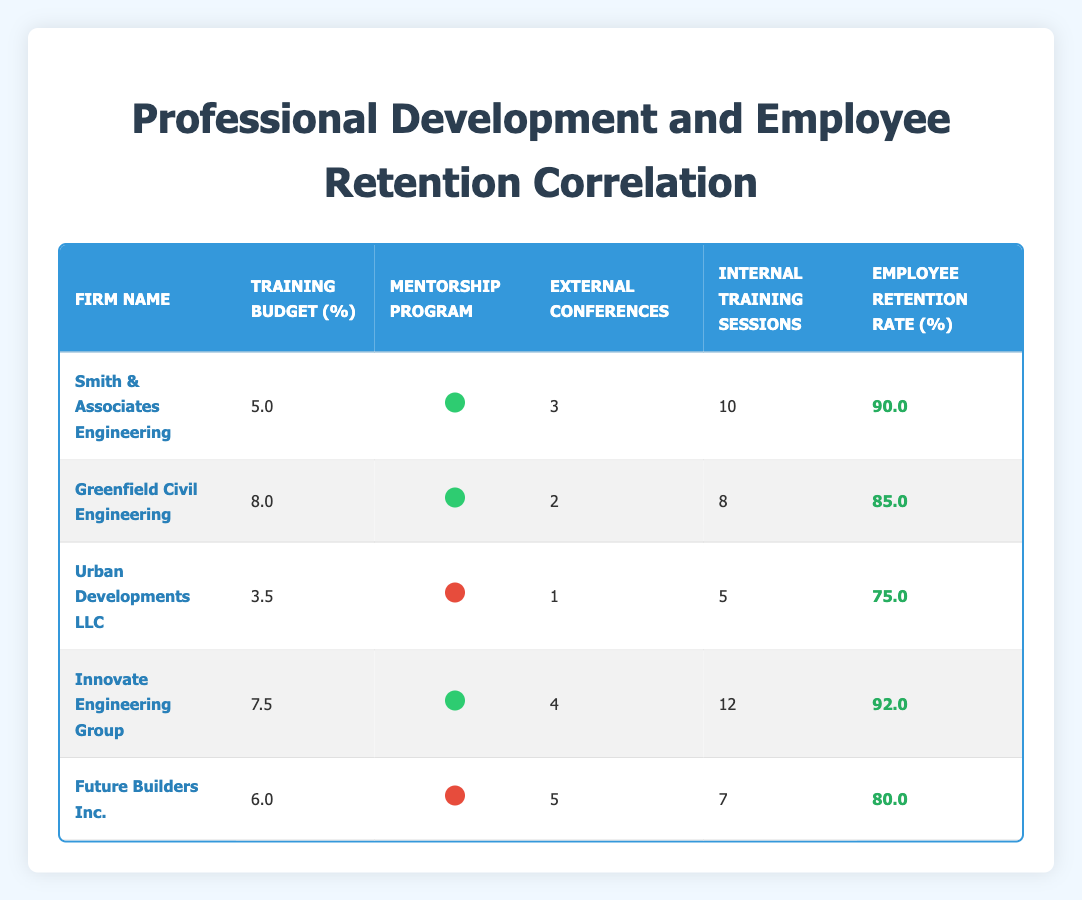What is the employee retention rate for Innovate Engineering Group? Looking at the table, the row for Innovate Engineering Group shows that the employee retention rate is listed as 92.0.
Answer: 92.0 How many external conferences did Future Builders Inc. attend? In the table, the data for Future Builders Inc. indicates that they attended 5 external conferences.
Answer: 5 Which firm has the highest training budget percentage? By comparing the training budget percentages from all firms in the table, Innovate Engineering Group has the highest at 7.5.
Answer: 7.5 Is there a mentorship program at Urban Developments LLC? The table shows that Urban Developments LLC has 0 under the mentorship program column, indicating they do not have a mentorship program.
Answer: No What is the average employee retention rate for firms with a mentorship program? The relevant firms with a mentorship program are Smith & Associates Engineering (90), Greenfield Civil Engineering (85), Innovate Engineering Group (92). Adding these gives 90 + 85 + 92 = 267. Then divide by 3 (the number of firms) to get an average of 89.0.
Answer: 89.0 Which firm with a mentorship program has the most internal training sessions? Looking at the firms with a mentorship program, Smith & Associates Engineering has 10 internal training sessions, while Innovate Engineering Group has 12. Thus, Innovate Engineering Group has the most internal training sessions at 12.
Answer: Innovate Engineering Group How many firms have an employee retention rate of 80% or higher? From the table, the firms meeting this criteria are Smith & Associates Engineering (90), Greenfield Civil Engineering (85), Innovate Engineering Group (92), and Future Builders Inc. (80), making a total of 4 firms.
Answer: 4 What is the total training budget percentage for firms without a mentorship program? The firms without a mentorship program are Urban Developments LLC (3.5) and Future Builders Inc. (6.0). Adding these percentages gives 3.5 + 6.0 = 9.5.
Answer: 9.5 Which firm has the lowest employee retention rate, and what is that rate? By reviewing the employee retention rates provided, Urban Developments LLC has the lowest rate at 75.0.
Answer: Urban Developments LLC, 75.0 